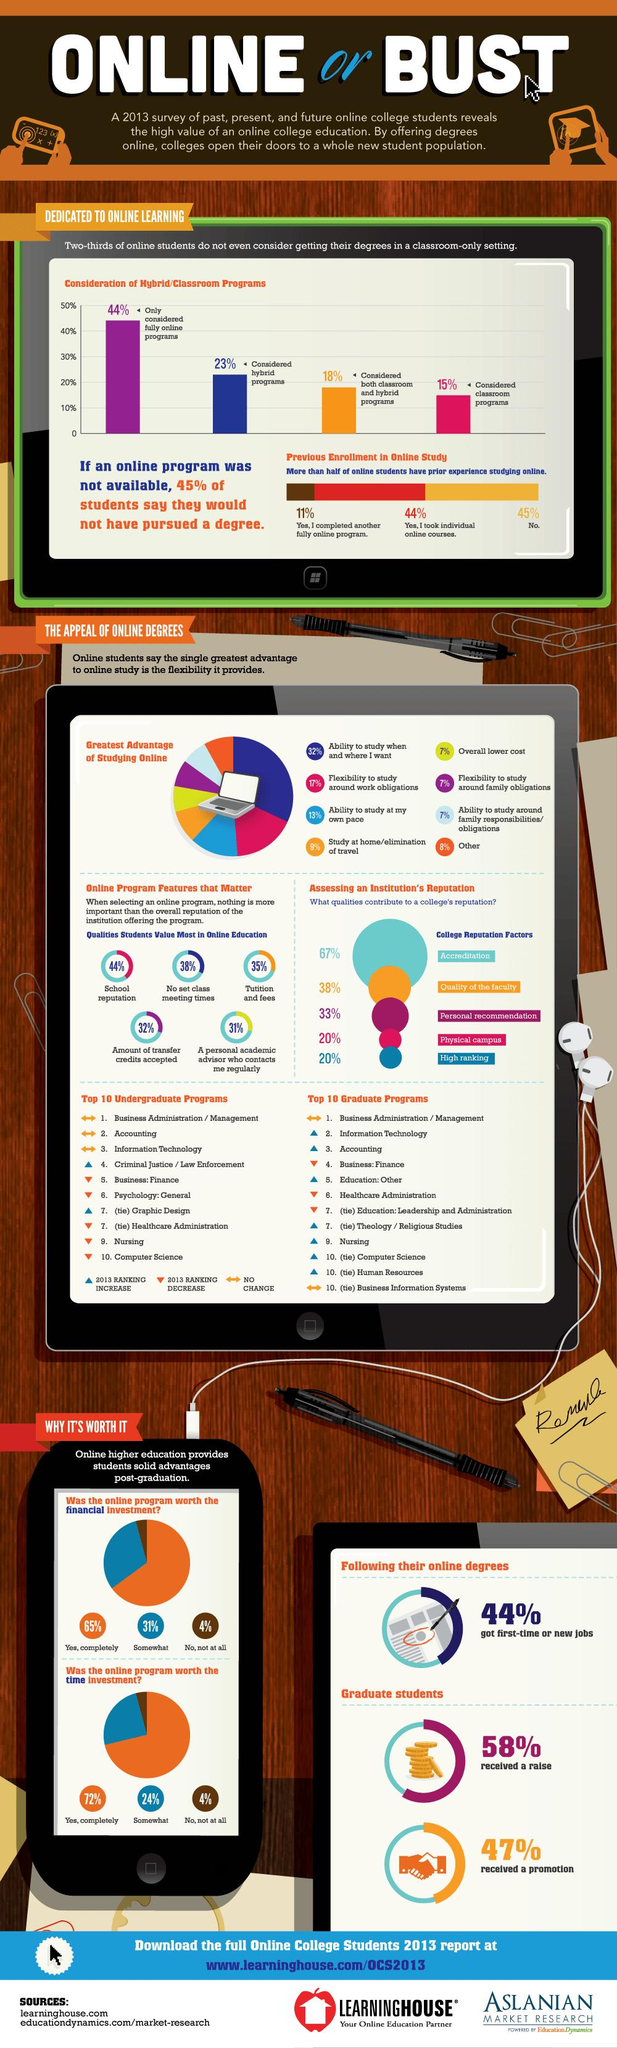Specify some key components in this picture. According to the 2013 survey, 65% of students completely agreed that the online program was worth the financial investment. According to a 2013 survey, 72% of students completely agreed that the online program was worth the time investment. According to a 2013 survey, a mere 4% of students do not agree that the online program was worth the time investment. According to a 2013 survey, only 4% of students do not agree that the online program was worth the financial investment. According to the 2013 survey, 23% of students considered hybrid programs. 